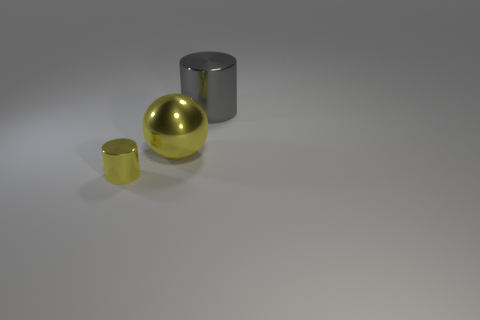There is a cylinder to the left of the gray cylinder; what is its size?
Your answer should be very brief. Small. Is the number of big yellow metallic things less than the number of big green cylinders?
Provide a short and direct response. No. Are there any objects of the same color as the large cylinder?
Offer a very short reply. No. There is a metallic thing that is to the left of the large gray metal object and behind the small shiny cylinder; what shape is it?
Your response must be concise. Sphere. There is a big thing in front of the shiny cylinder that is behind the yellow metal cylinder; what is its shape?
Your answer should be very brief. Sphere. Do the large yellow thing and the large gray shiny object have the same shape?
Make the answer very short. No. There is a cylinder that is the same color as the sphere; what is its material?
Your answer should be very brief. Metal. Is the color of the ball the same as the tiny metallic cylinder?
Provide a succinct answer. Yes. There is a gray shiny object behind the shiny thing that is on the left side of the metallic ball; how many gray metal cylinders are on the right side of it?
Your answer should be compact. 0. What is the shape of the other yellow thing that is made of the same material as the tiny thing?
Your answer should be compact. Sphere. 